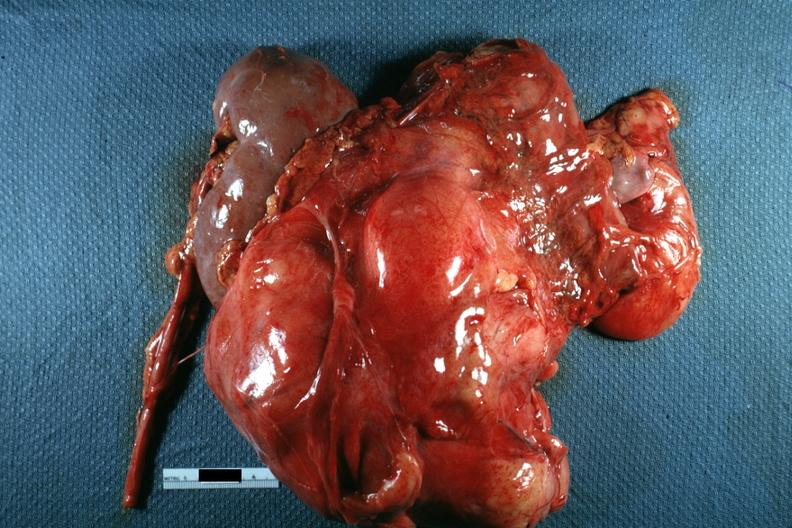how many side does this image show nodular mass with kidney seen on photo of little use without showing cut surface?
Answer the question using a single word or phrase. One 